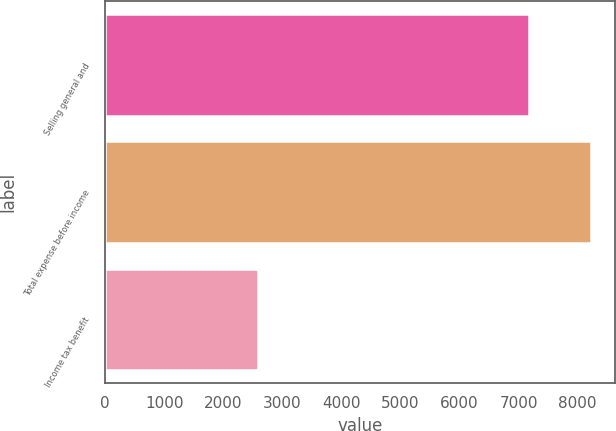Convert chart. <chart><loc_0><loc_0><loc_500><loc_500><bar_chart><fcel>Selling general and<fcel>Total expense before income<fcel>Income tax benefit<nl><fcel>7175<fcel>8218<fcel>2585<nl></chart> 